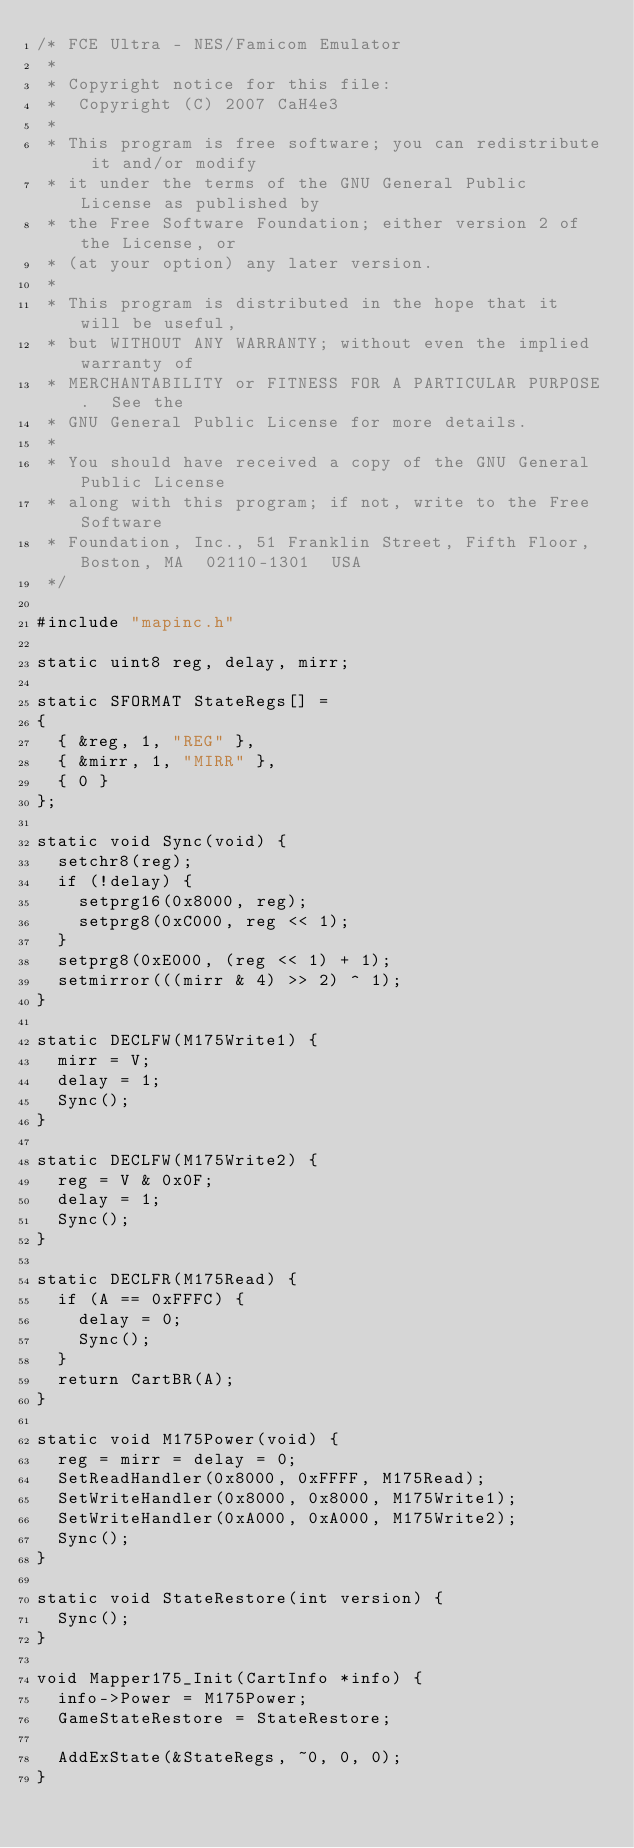Convert code to text. <code><loc_0><loc_0><loc_500><loc_500><_C++_>/* FCE Ultra - NES/Famicom Emulator
 *
 * Copyright notice for this file:
 *  Copyright (C) 2007 CaH4e3
 *
 * This program is free software; you can redistribute it and/or modify
 * it under the terms of the GNU General Public License as published by
 * the Free Software Foundation; either version 2 of the License, or
 * (at your option) any later version.
 *
 * This program is distributed in the hope that it will be useful,
 * but WITHOUT ANY WARRANTY; without even the implied warranty of
 * MERCHANTABILITY or FITNESS FOR A PARTICULAR PURPOSE.  See the
 * GNU General Public License for more details.
 *
 * You should have received a copy of the GNU General Public License
 * along with this program; if not, write to the Free Software
 * Foundation, Inc., 51 Franklin Street, Fifth Floor, Boston, MA  02110-1301  USA
 */

#include "mapinc.h"

static uint8 reg, delay, mirr;

static SFORMAT StateRegs[] =
{
	{ &reg, 1, "REG" },
	{ &mirr, 1, "MIRR" },
	{ 0 }
};

static void Sync(void) {
	setchr8(reg);
	if (!delay) {
		setprg16(0x8000, reg);
		setprg8(0xC000, reg << 1);
	}
	setprg8(0xE000, (reg << 1) + 1);
	setmirror(((mirr & 4) >> 2) ^ 1);
}

static DECLFW(M175Write1) {
	mirr = V;
	delay = 1;
	Sync();
}

static DECLFW(M175Write2) {
	reg = V & 0x0F;
	delay = 1;
	Sync();
}

static DECLFR(M175Read) {
	if (A == 0xFFFC) {
		delay = 0;
		Sync();
	}
	return CartBR(A);
}

static void M175Power(void) {
	reg = mirr = delay = 0;
	SetReadHandler(0x8000, 0xFFFF, M175Read);
	SetWriteHandler(0x8000, 0x8000, M175Write1);
	SetWriteHandler(0xA000, 0xA000, M175Write2);
	Sync();
}

static void StateRestore(int version) {
	Sync();
}

void Mapper175_Init(CartInfo *info) {
	info->Power = M175Power;
	GameStateRestore = StateRestore;

	AddExState(&StateRegs, ~0, 0, 0);
}
</code> 